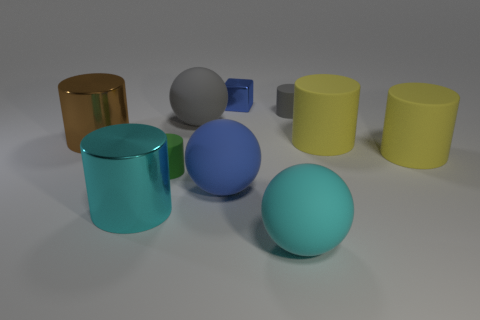Subtract all cyan cylinders. How many cylinders are left? 5 Subtract all big rubber cylinders. How many cylinders are left? 4 Subtract all blue cylinders. Subtract all yellow cubes. How many cylinders are left? 6 Subtract all cylinders. How many objects are left? 4 Add 8 large shiny cylinders. How many large shiny cylinders exist? 10 Subtract 0 purple cylinders. How many objects are left? 10 Subtract all big shiny things. Subtract all cyan objects. How many objects are left? 6 Add 6 large cyan objects. How many large cyan objects are left? 8 